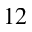<formula> <loc_0><loc_0><loc_500><loc_500>^ { 1 2 }</formula> 